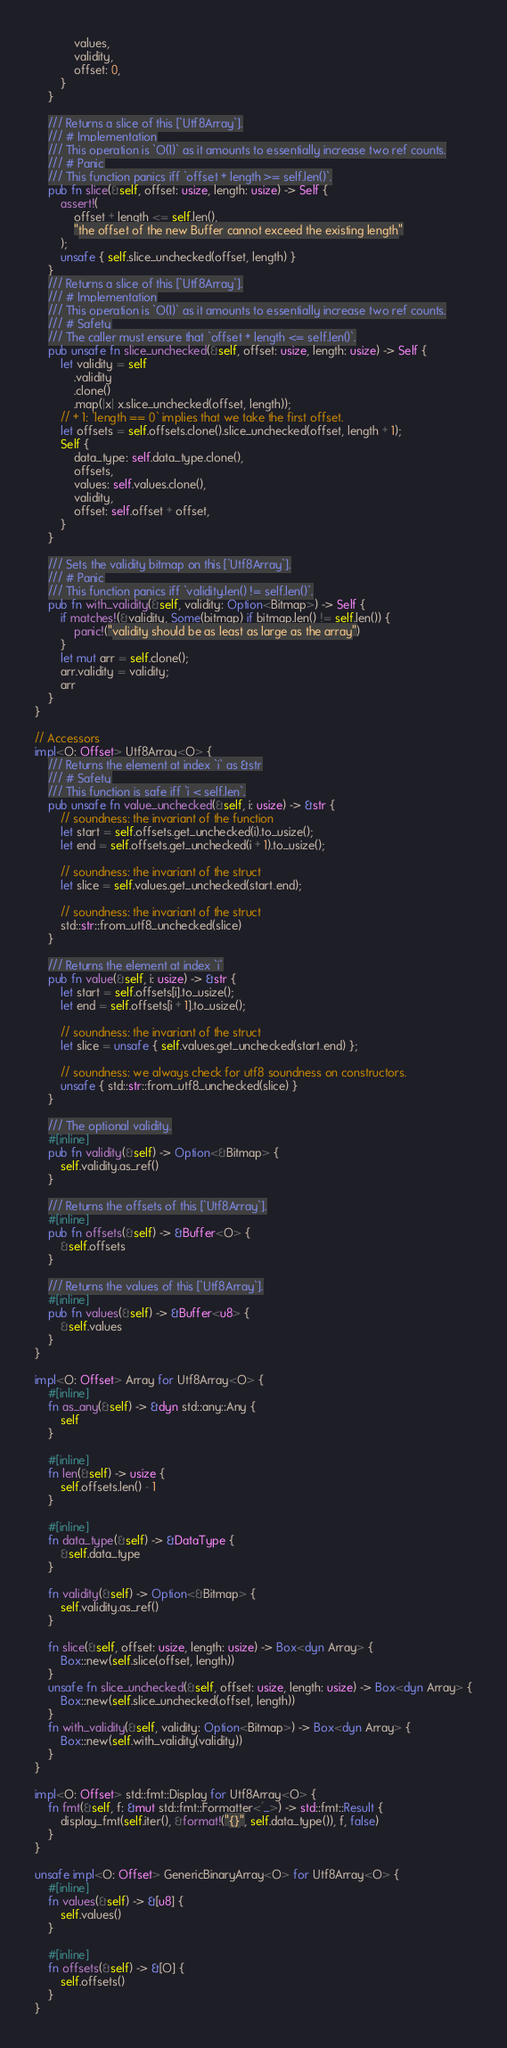Convert code to text. <code><loc_0><loc_0><loc_500><loc_500><_Rust_>            values,
            validity,
            offset: 0,
        }
    }

    /// Returns a slice of this [`Utf8Array`].
    /// # Implementation
    /// This operation is `O(1)` as it amounts to essentially increase two ref counts.
    /// # Panic
    /// This function panics iff `offset + length >= self.len()`.
    pub fn slice(&self, offset: usize, length: usize) -> Self {
        assert!(
            offset + length <= self.len(),
            "the offset of the new Buffer cannot exceed the existing length"
        );
        unsafe { self.slice_unchecked(offset, length) }
    }
    /// Returns a slice of this [`Utf8Array`].
    /// # Implementation
    /// This operation is `O(1)` as it amounts to essentially increase two ref counts.
    /// # Safety
    /// The caller must ensure that `offset + length <= self.len()`.
    pub unsafe fn slice_unchecked(&self, offset: usize, length: usize) -> Self {
        let validity = self
            .validity
            .clone()
            .map(|x| x.slice_unchecked(offset, length));
        // + 1: `length == 0` implies that we take the first offset.
        let offsets = self.offsets.clone().slice_unchecked(offset, length + 1);
        Self {
            data_type: self.data_type.clone(),
            offsets,
            values: self.values.clone(),
            validity,
            offset: self.offset + offset,
        }
    }

    /// Sets the validity bitmap on this [`Utf8Array`].
    /// # Panic
    /// This function panics iff `validity.len() != self.len()`.
    pub fn with_validity(&self, validity: Option<Bitmap>) -> Self {
        if matches!(&validity, Some(bitmap) if bitmap.len() != self.len()) {
            panic!("validity should be as least as large as the array")
        }
        let mut arr = self.clone();
        arr.validity = validity;
        arr
    }
}

// Accessors
impl<O: Offset> Utf8Array<O> {
    /// Returns the element at index `i` as &str
    /// # Safety
    /// This function is safe iff `i < self.len`.
    pub unsafe fn value_unchecked(&self, i: usize) -> &str {
        // soundness: the invariant of the function
        let start = self.offsets.get_unchecked(i).to_usize();
        let end = self.offsets.get_unchecked(i + 1).to_usize();

        // soundness: the invariant of the struct
        let slice = self.values.get_unchecked(start..end);

        // soundness: the invariant of the struct
        std::str::from_utf8_unchecked(slice)
    }

    /// Returns the element at index `i`
    pub fn value(&self, i: usize) -> &str {
        let start = self.offsets[i].to_usize();
        let end = self.offsets[i + 1].to_usize();

        // soundness: the invariant of the struct
        let slice = unsafe { self.values.get_unchecked(start..end) };

        // soundness: we always check for utf8 soundness on constructors.
        unsafe { std::str::from_utf8_unchecked(slice) }
    }

    /// The optional validity.
    #[inline]
    pub fn validity(&self) -> Option<&Bitmap> {
        self.validity.as_ref()
    }

    /// Returns the offsets of this [`Utf8Array`].
    #[inline]
    pub fn offsets(&self) -> &Buffer<O> {
        &self.offsets
    }

    /// Returns the values of this [`Utf8Array`].
    #[inline]
    pub fn values(&self) -> &Buffer<u8> {
        &self.values
    }
}

impl<O: Offset> Array for Utf8Array<O> {
    #[inline]
    fn as_any(&self) -> &dyn std::any::Any {
        self
    }

    #[inline]
    fn len(&self) -> usize {
        self.offsets.len() - 1
    }

    #[inline]
    fn data_type(&self) -> &DataType {
        &self.data_type
    }

    fn validity(&self) -> Option<&Bitmap> {
        self.validity.as_ref()
    }

    fn slice(&self, offset: usize, length: usize) -> Box<dyn Array> {
        Box::new(self.slice(offset, length))
    }
    unsafe fn slice_unchecked(&self, offset: usize, length: usize) -> Box<dyn Array> {
        Box::new(self.slice_unchecked(offset, length))
    }
    fn with_validity(&self, validity: Option<Bitmap>) -> Box<dyn Array> {
        Box::new(self.with_validity(validity))
    }
}

impl<O: Offset> std::fmt::Display for Utf8Array<O> {
    fn fmt(&self, f: &mut std::fmt::Formatter<'_>) -> std::fmt::Result {
        display_fmt(self.iter(), &format!("{}", self.data_type()), f, false)
    }
}

unsafe impl<O: Offset> GenericBinaryArray<O> for Utf8Array<O> {
    #[inline]
    fn values(&self) -> &[u8] {
        self.values()
    }

    #[inline]
    fn offsets(&self) -> &[O] {
        self.offsets()
    }
}
</code> 